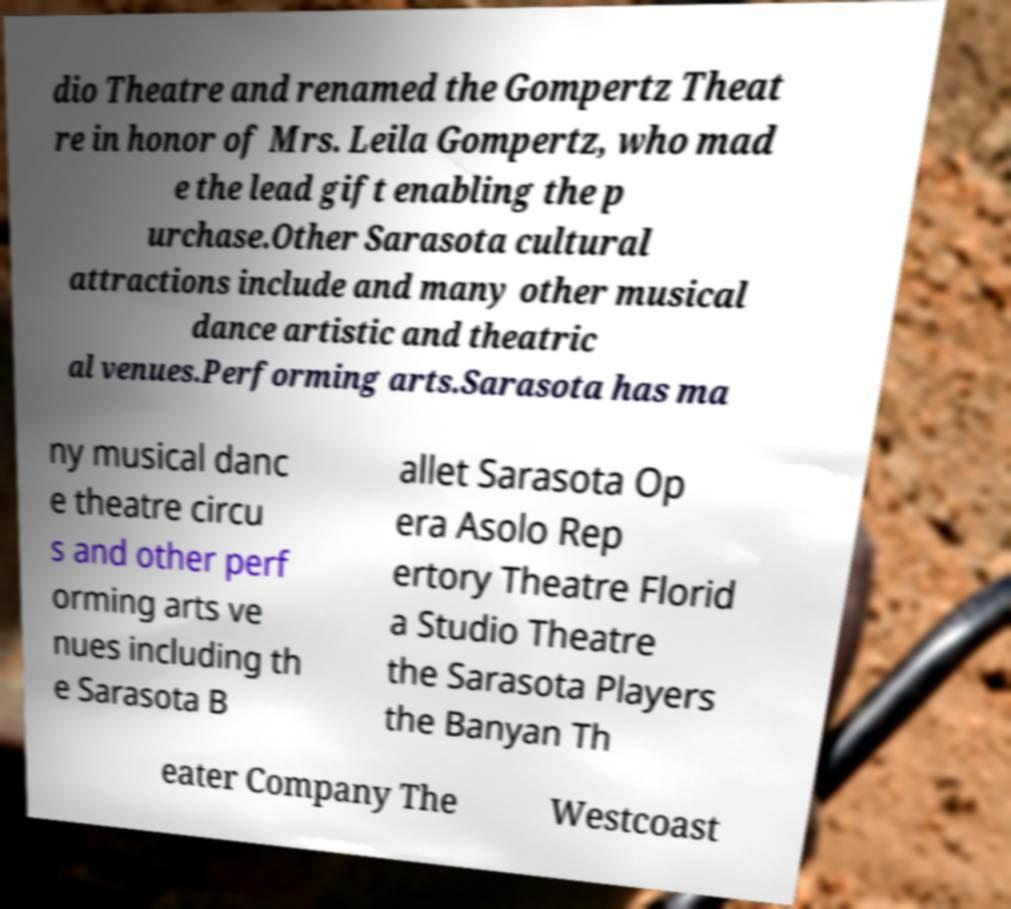Can you read and provide the text displayed in the image?This photo seems to have some interesting text. Can you extract and type it out for me? dio Theatre and renamed the Gompertz Theat re in honor of Mrs. Leila Gompertz, who mad e the lead gift enabling the p urchase.Other Sarasota cultural attractions include and many other musical dance artistic and theatric al venues.Performing arts.Sarasota has ma ny musical danc e theatre circu s and other perf orming arts ve nues including th e Sarasota B allet Sarasota Op era Asolo Rep ertory Theatre Florid a Studio Theatre the Sarasota Players the Banyan Th eater Company The Westcoast 